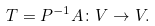<formula> <loc_0><loc_0><loc_500><loc_500>T = P ^ { - 1 } A \colon V \rightarrow V .</formula> 